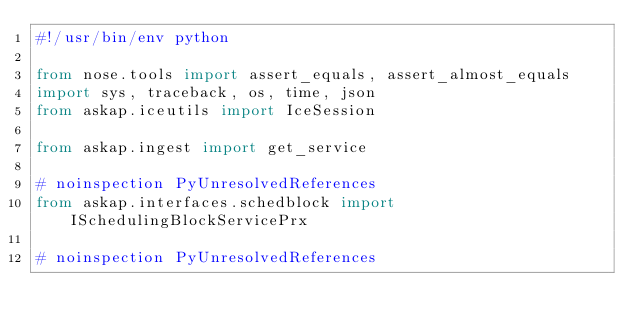Convert code to text. <code><loc_0><loc_0><loc_500><loc_500><_Python_>#!/usr/bin/env python

from nose.tools import assert_equals, assert_almost_equals
import sys, traceback, os, time, json
from askap.iceutils import IceSession

from askap.ingest import get_service

# noinspection PyUnresolvedReferences
from askap.interfaces.schedblock import ISchedulingBlockServicePrx

# noinspection PyUnresolvedReferences</code> 